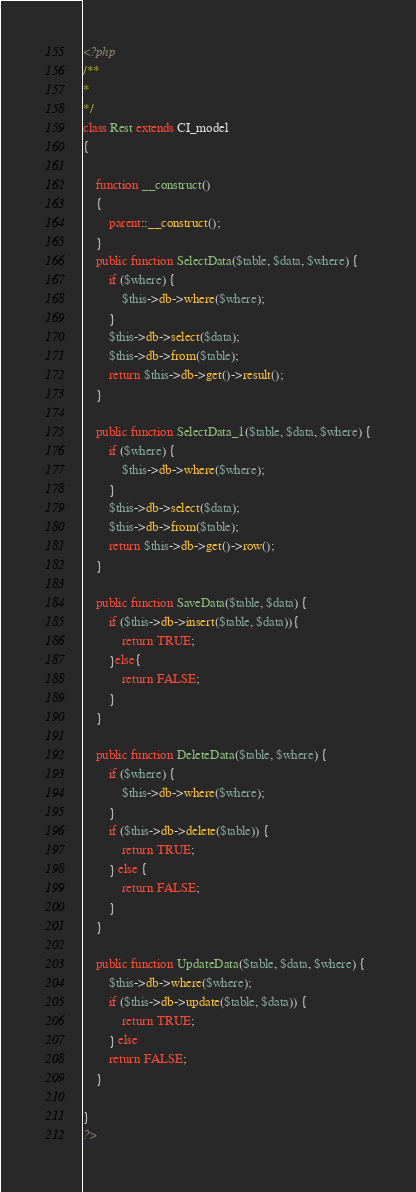<code> <loc_0><loc_0><loc_500><loc_500><_PHP_><?php
/**
* 
*/
class Rest extends CI_model
{
	
	function __construct()
	{
		parent::__construct();
	}
	public function SelectData($table, $data, $where) {
		if ($where) {
			$this->db->where($where);
		}
		$this->db->select($data);
		$this->db->from($table);
		return $this->db->get()->result();
	}

	public function SelectData_1($table, $data, $where) {
		if ($where) {
			$this->db->where($where);
		}
		$this->db->select($data);
		$this->db->from($table);
		return $this->db->get()->row();
	}

	public function SaveData($table, $data) {
		if ($this->db->insert($table, $data)){
			return TRUE;
		}else{
			return FALSE;
		}
	}

	public function DeleteData($table, $where) {
		if ($where) {
			$this->db->where($where);
		}
		if ($this->db->delete($table)) {
			return TRUE;
		} else {
			return FALSE;
		}
	}

	public function UpdateData($table, $data, $where) {
		$this->db->where($where);
		if ($this->db->update($table, $data)) {
			return TRUE;
		} else
		return FALSE;
	}

}
?></code> 